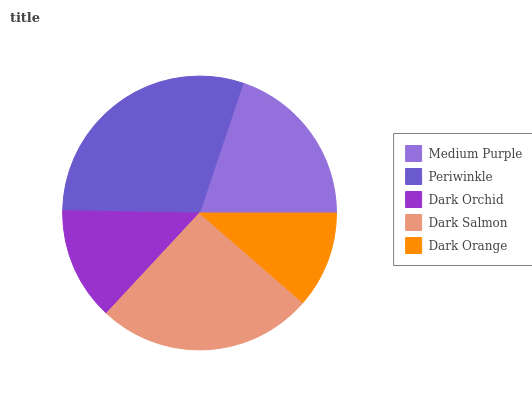Is Dark Orange the minimum?
Answer yes or no. Yes. Is Periwinkle the maximum?
Answer yes or no. Yes. Is Dark Orchid the minimum?
Answer yes or no. No. Is Dark Orchid the maximum?
Answer yes or no. No. Is Periwinkle greater than Dark Orchid?
Answer yes or no. Yes. Is Dark Orchid less than Periwinkle?
Answer yes or no. Yes. Is Dark Orchid greater than Periwinkle?
Answer yes or no. No. Is Periwinkle less than Dark Orchid?
Answer yes or no. No. Is Medium Purple the high median?
Answer yes or no. Yes. Is Medium Purple the low median?
Answer yes or no. Yes. Is Dark Orange the high median?
Answer yes or no. No. Is Dark Orange the low median?
Answer yes or no. No. 